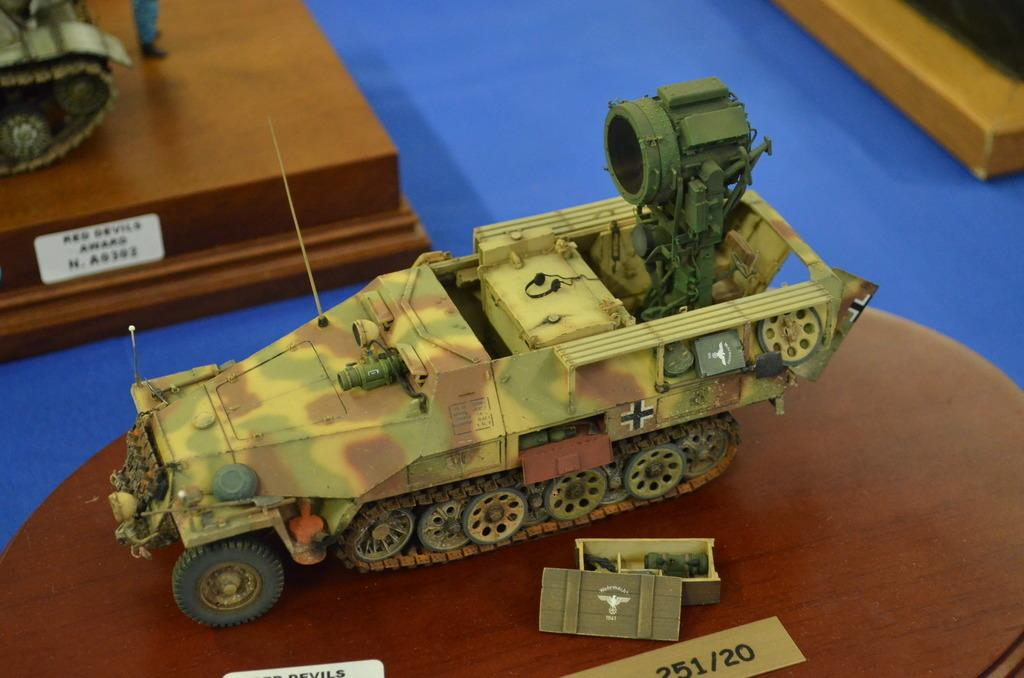What is the main subject of the image? The main subject of the image is a catalog of army tanks. Are there any other objects featured in the catalog? Yes, the catalog contains other objects besides army tanks. Where is the catalog located in the image? The catalog is placed on a table. Can you describe the background of the image? The background of the image is blurred. What type of brass instrument is being played by the dinosaur in the image? There are no brass instruments or dinosaurs present in the image. What color is the sweater worn by the person holding the catalog in the image? There is no person holding the catalog in the image, and therefore no sweater can be observed. 